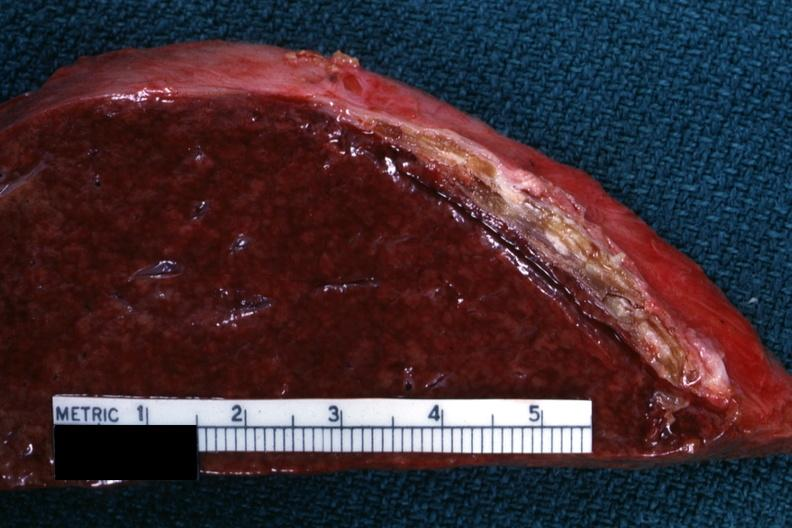does 70yof show cut surface showing very thickened capsule with focal calcification very good close-up photo?
Answer the question using a single word or phrase. No 